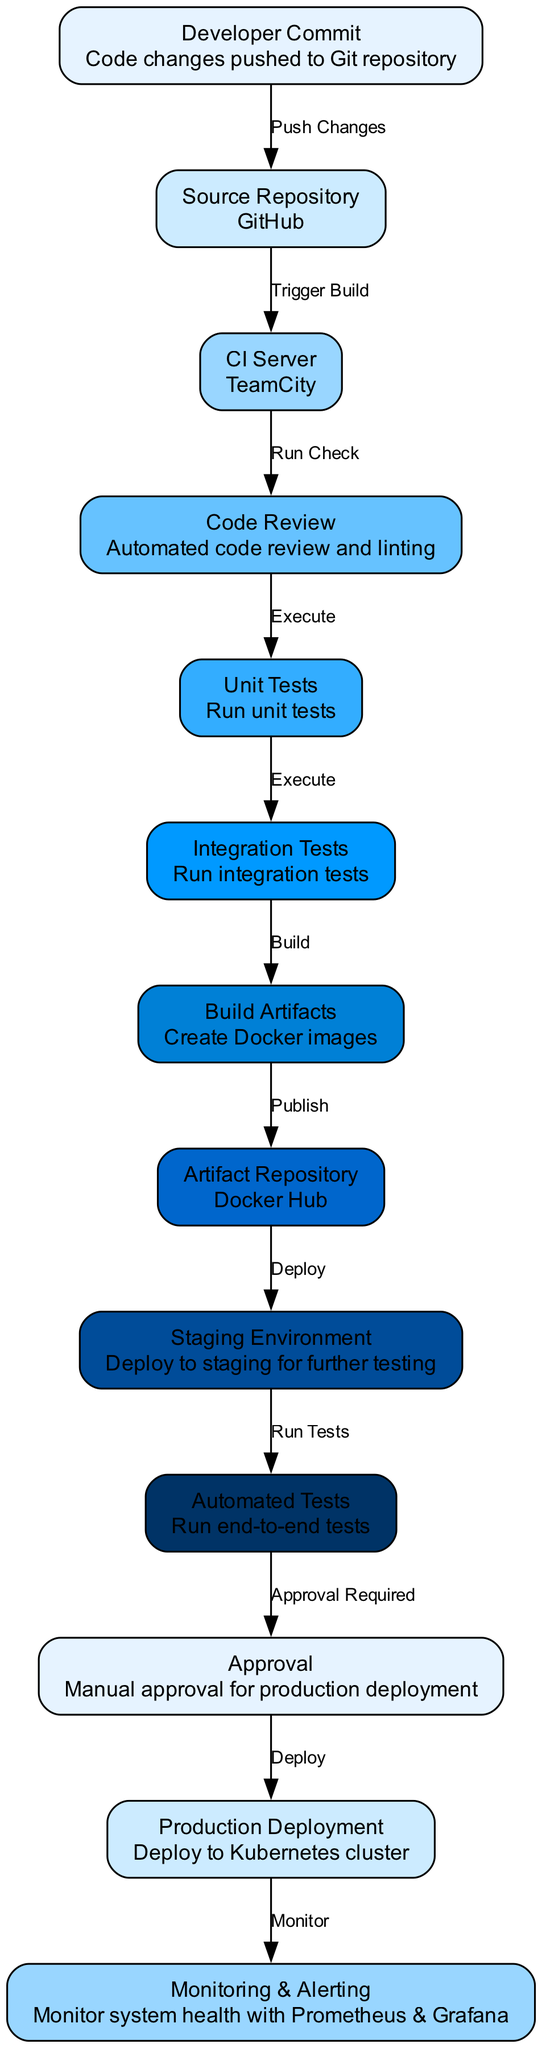What is the final node in the CI/CD pipeline? The diagram outlines the process from code commit to production deployment, and the final node is labeled "Monitoring & Alerting," indicating that after the deployment, the system's health is monitored.
Answer: Monitoring & Alerting How many nodes are present in the diagram? By counting each unique node labeled from the Developer Commit to Monitoring & Alerting, there are a total of thirteen different nodes illustrated in the diagram.
Answer: Thirteen What type of repository is specified for the source code? The diagram indicates that the "Source Repository" is GitHub, denoting the platform where the source code resides and is managed.
Answer: GitHub What triggers the build process in TeamCity? The diagram specifies that after pushing changes to the Git repository, this action triggers a build in the TeamCity, indicating the workflow starts here.
Answer: Push Changes What stage comes before unit tests in the pipeline? From the diagram's flow, the "Code Review" stage takes place immediately before unit tests, indicating it's essential to review the code before testing.
Answer: Code Review How many approval steps are in the pipeline before production deployment? The diagram clearly shows there is one "Approval" step required before proceeding to the "Production Deployment," indicating a necessary manual verification phase.
Answer: One Which node indicates the automated testing phase after deployment to staging? The node labeled "Automated Tests" indicates the phase where end-to-end tests are executed after the application is deployed to the staging environment.
Answer: Automated Tests What is the edge label connecting unit tests and integration tests? The edge that connects these two nodes is labeled "Execute," signifying that unit tests are run before integration tests in the CI/CD process.
Answer: Execute Where are the build artifacts published? The diagram states that the "Build Artifacts" are published to the "Artifact Repository," specifically to Docker Hub, where images are stored.
Answer: Docker Hub 